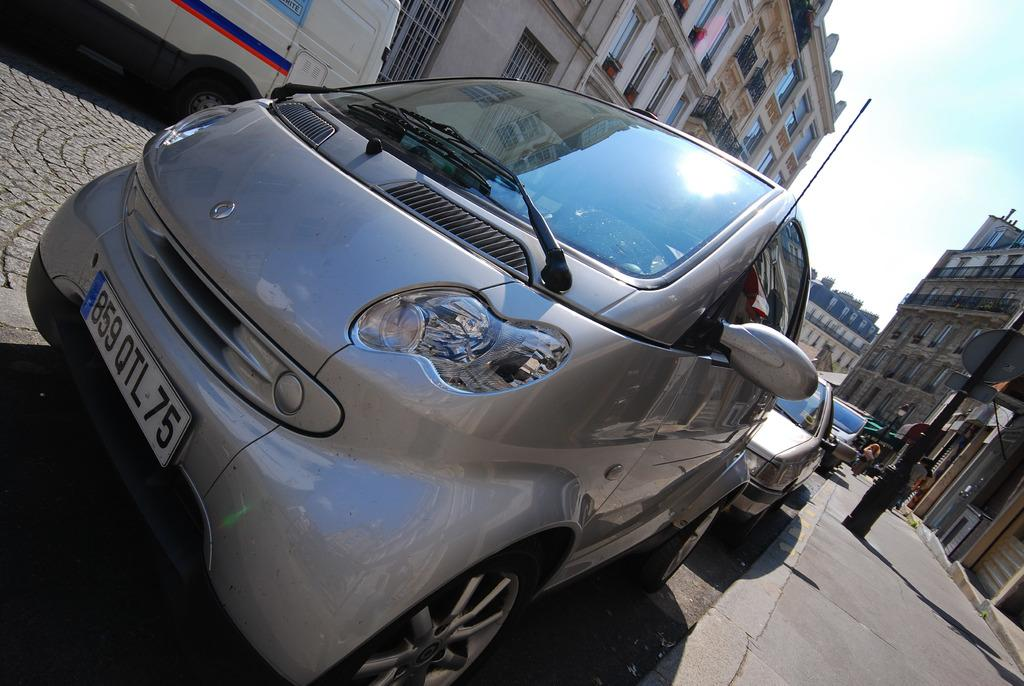What is present on the road in the image? There are vehicles on the road in the image. What can be seen alongside the road in the image? There is a footpath in the image. What type of structures are visible in the image? There are buildings with windows in the image. What is visible in the background of the image? The sky is visible in the background of the image. Can you tell me how many toes are visible on the vehicles in the image? There are no toes present on the vehicles in the image; they are vehicles, not living beings. What type of bite can be seen on the buildings in the image? There is no bite present on the buildings in the image; they are buildings, not food. 